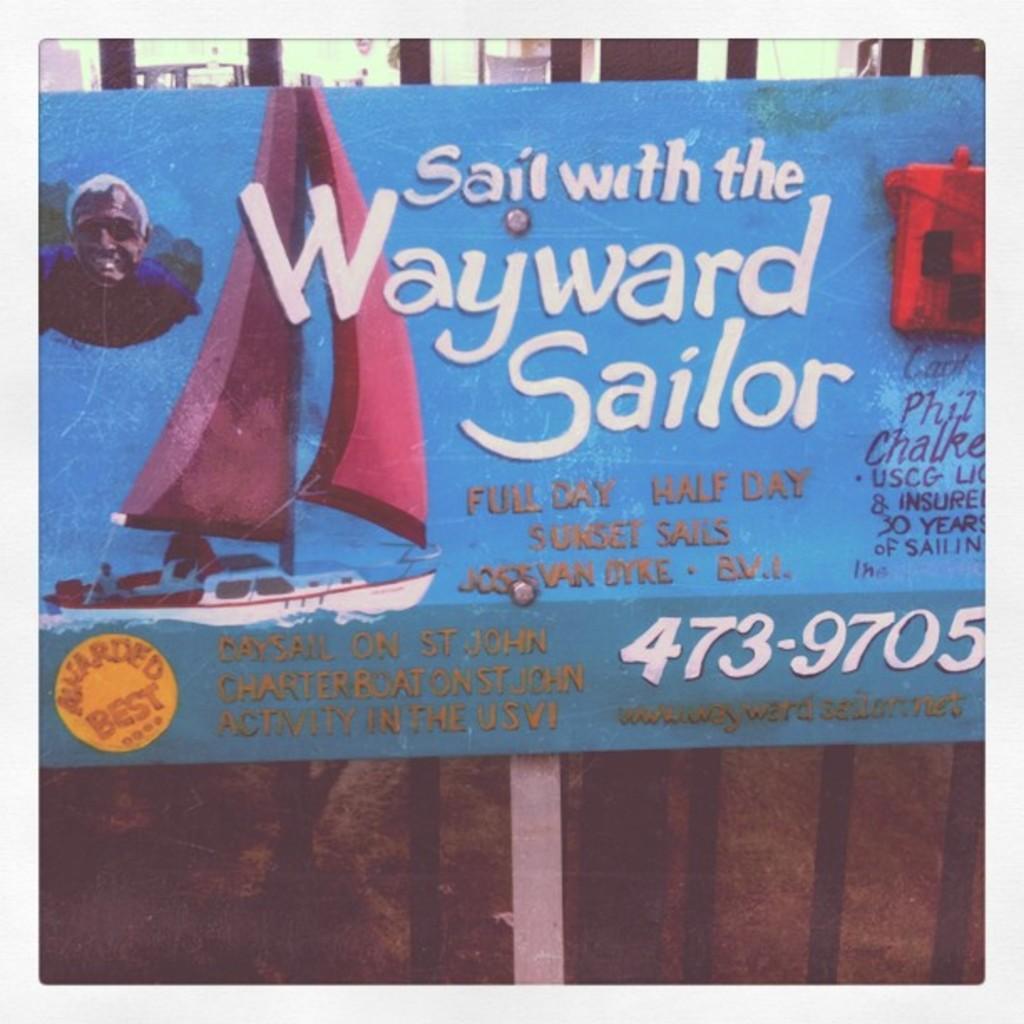Can you describe this image briefly? In the center of the image there is a placard with some text on it. 